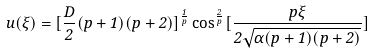Convert formula to latex. <formula><loc_0><loc_0><loc_500><loc_500>u ( \xi ) = [ \frac { D } { 2 } ( p + 1 ) ( p + 2 ) ] ^ { \frac { 1 } { p } } \cos ^ { \frac { 2 } { p } } [ \frac { p \xi } { 2 \sqrt { \alpha ( p + 1 ) ( p + 2 ) } } ]</formula> 